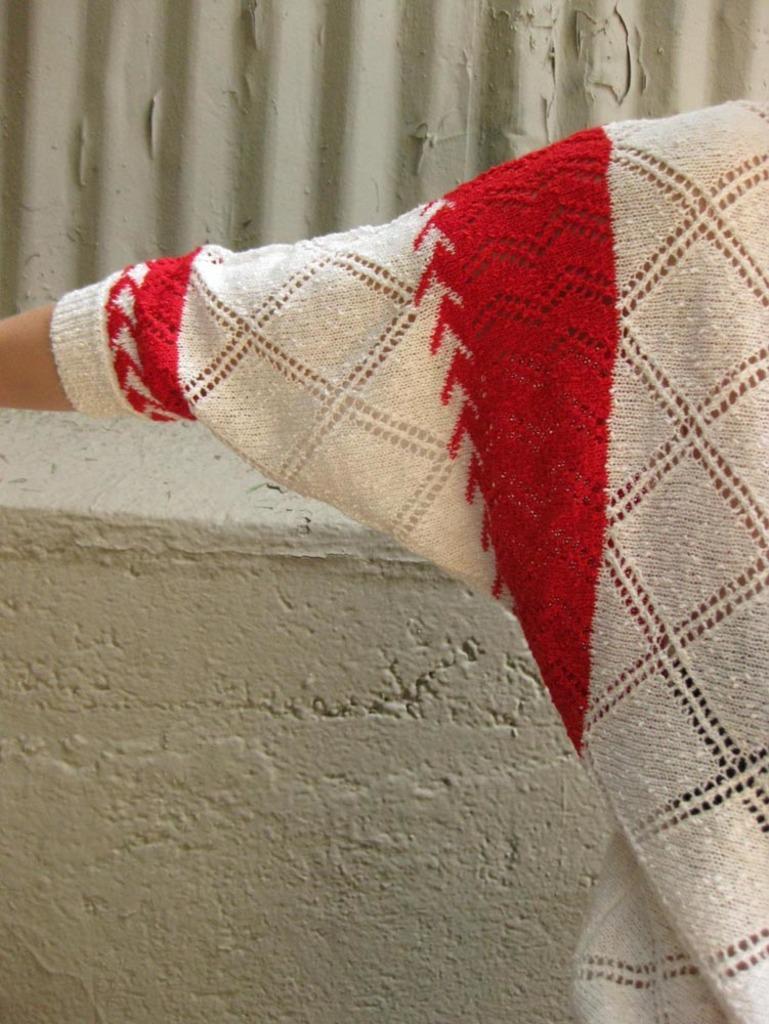Please provide a concise description of this image. In this image I can see at the bottom there is the wall, in the middle it looks like a human hand, this person is wearing the sweater. 